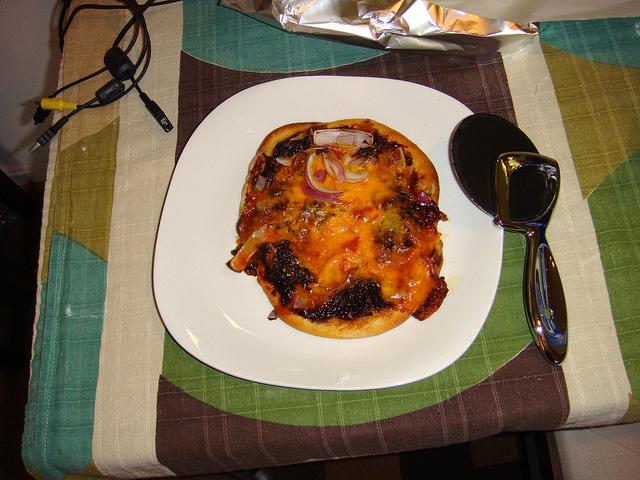What is on the table, to the top left of the plate?
Be succinct. Cable. What is the utensil on the right side of the plate?
Keep it brief. Pizza cutter. Do you think this dish looks appealing?
Short answer required. No. Is this plate dishwasher safe?
Be succinct. Yes. 